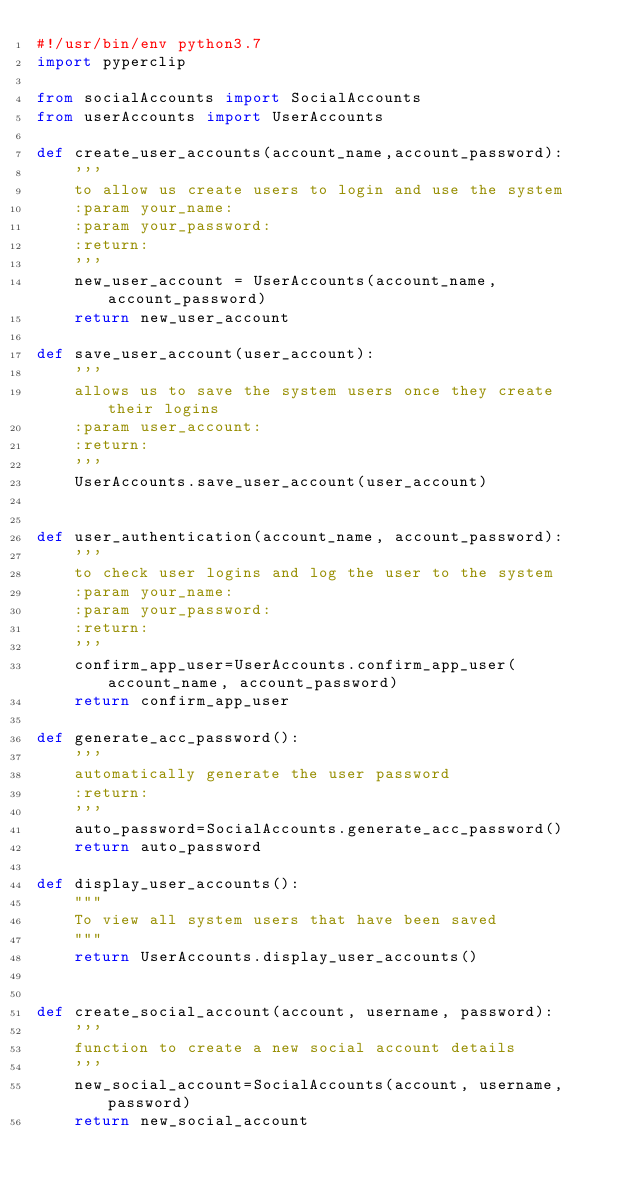Convert code to text. <code><loc_0><loc_0><loc_500><loc_500><_Python_>#!/usr/bin/env python3.7
import pyperclip

from socialAccounts import SocialAccounts
from userAccounts import UserAccounts

def create_user_accounts(account_name,account_password):
    '''
    to allow us create users to login and use the system
    :param your_name:
    :param your_password:
    :return:
    '''
    new_user_account = UserAccounts(account_name, account_password)
    return new_user_account

def save_user_account(user_account):
    '''
    allows us to save the system users once they create their logins
    :param user_account:
    :return:
    '''
    UserAccounts.save_user_account(user_account)


def user_authentication(account_name, account_password):
    '''
    to check user logins and log the user to the system
    :param your_name:
    :param your_password:
    :return:
    '''
    confirm_app_user=UserAccounts.confirm_app_user(account_name, account_password)
    return confirm_app_user

def generate_acc_password():
    '''
    automatically generate the user password
    :return:
    '''
    auto_password=SocialAccounts.generate_acc_password()
    return auto_password

def display_user_accounts():
    """
    To view all system users that have been saved
    """
    return UserAccounts.display_user_accounts()


def create_social_account(account, username, password):
    '''
    function to create a new social account details
    '''
    new_social_account=SocialAccounts(account, username, password)
    return new_social_account
</code> 